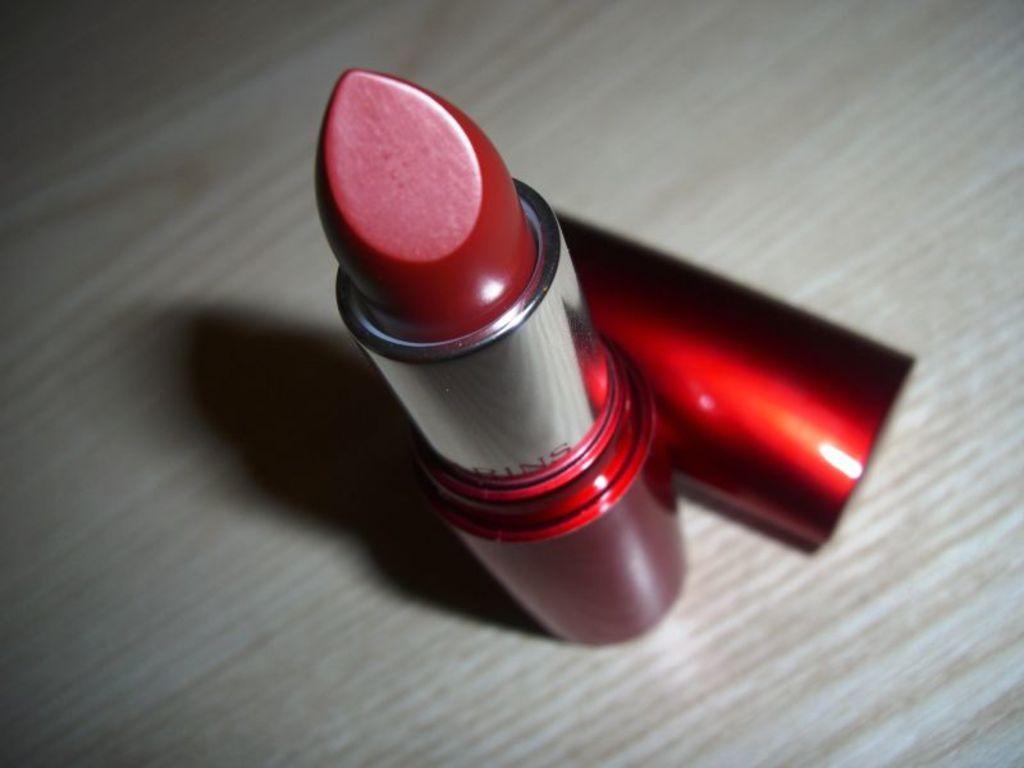In one or two sentences, can you explain what this image depicts? In this picture we can see red color lipstick, beside that we can see a cap on the table. 